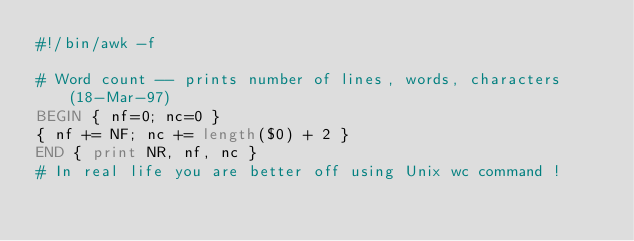<code> <loc_0><loc_0><loc_500><loc_500><_Awk_>#!/bin/awk -f

# Word count -- prints number of lines, words, characters    (18-Mar-97)
BEGIN { nf=0; nc=0 }
{ nf += NF; nc += length($0) + 2 } 
END { print NR, nf, nc }
# In real life you are better off using Unix wc command !
</code> 